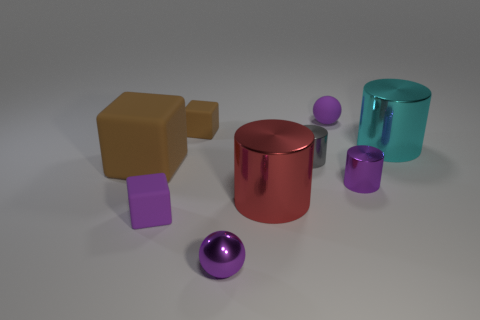What materials are the objects in the image made of? The image shows a variety of objects that seem to be made from different materials. The cube looks to be of a matte finish, likely resembling a plastic texture. The cylinders and the balls have reflective surfaces, which suggest they could be metal. Lastly, the object on the far left, a shape with a notch cut out, seems also to have a matte surface, much like the cube, suggesting a non-metallic material, possibly wood or plastic. 